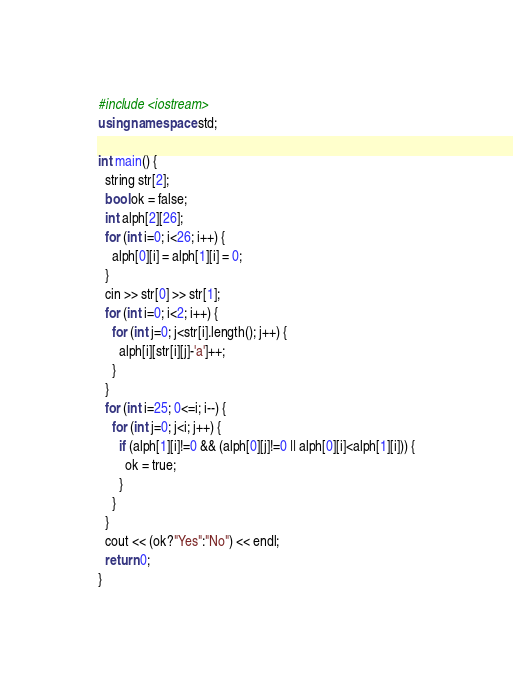<code> <loc_0><loc_0><loc_500><loc_500><_C++_>#include <iostream>
using namespace std;

int main() {
  string str[2];
  bool ok = false;
  int alph[2][26];
  for (int i=0; i<26; i++) {
    alph[0][i] = alph[1][i] = 0;
  }
  cin >> str[0] >> str[1];
  for (int i=0; i<2; i++) {
    for (int j=0; j<str[i].length(); j++) {
      alph[i][str[i][j]-'a']++;
    }
  }
  for (int i=25; 0<=i; i--) {
    for (int j=0; j<i; j++) {
      if (alph[1][i]!=0 && (alph[0][j]!=0 || alph[0][i]<alph[1][i])) {
        ok = true;
      }
    }
  }
  cout << (ok?"Yes":"No") << endl;
  return 0;
}</code> 